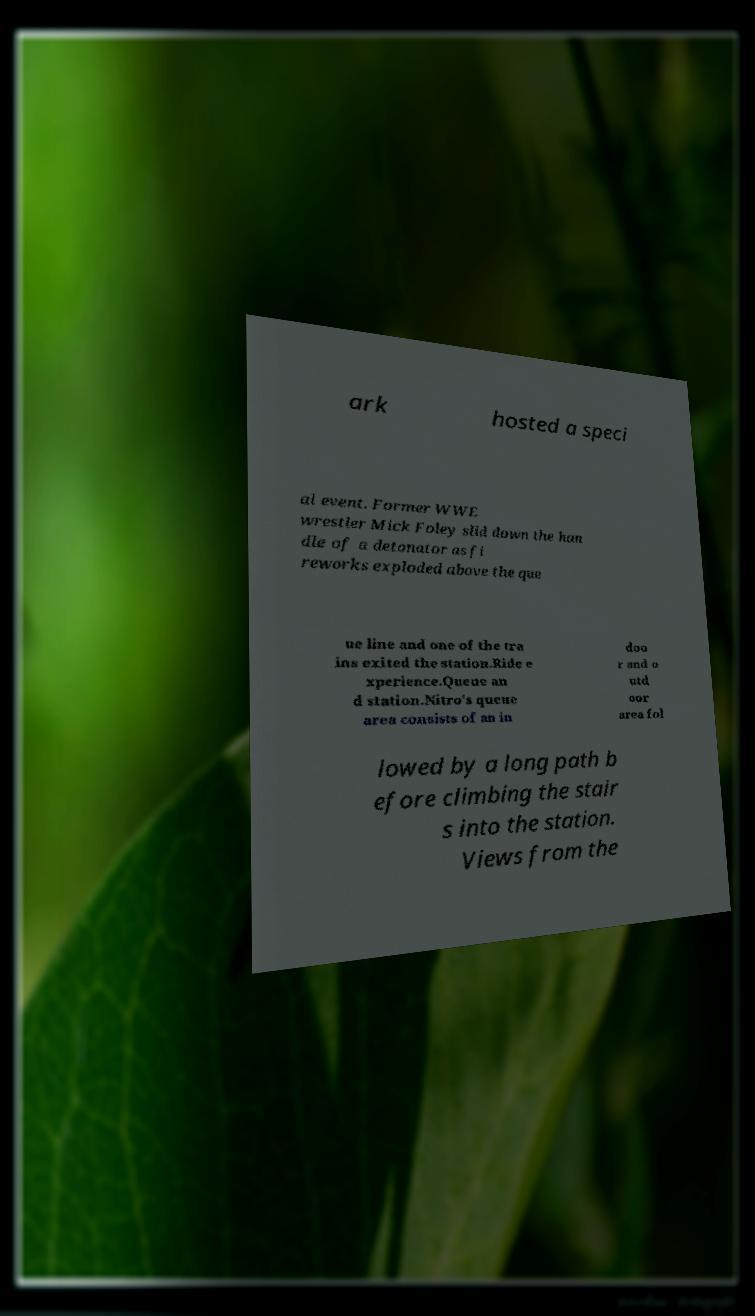Could you assist in decoding the text presented in this image and type it out clearly? ark hosted a speci al event. Former WWE wrestler Mick Foley slid down the han dle of a detonator as fi reworks exploded above the que ue line and one of the tra ins exited the station.Ride e xperience.Queue an d station.Nitro's queue area consists of an in doo r and o utd oor area fol lowed by a long path b efore climbing the stair s into the station. Views from the 